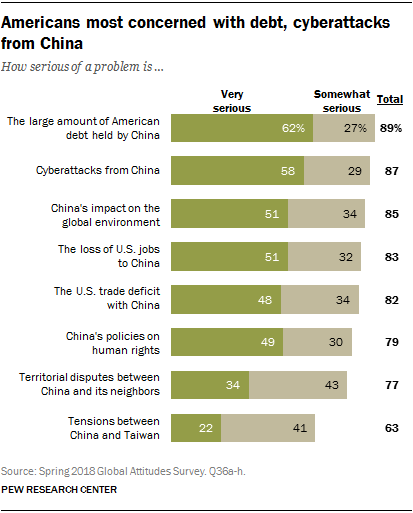Specify some key components in this picture. A significant percentage of Americans are very serious about the loss of jobs to China. It is estimated that approximately 4 out of every 10 issues have over 50% of people choosing the very serious response option. 